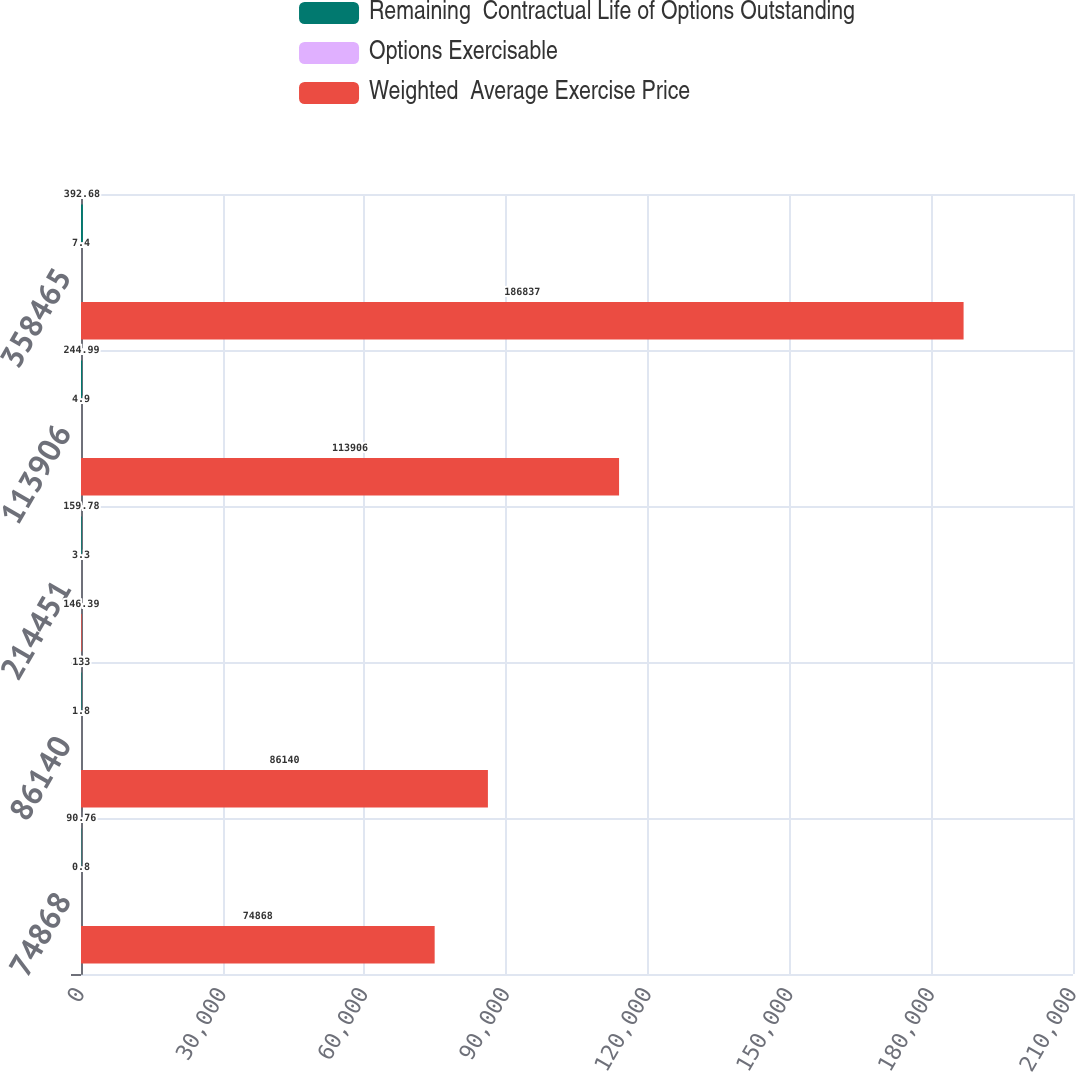Convert chart to OTSL. <chart><loc_0><loc_0><loc_500><loc_500><stacked_bar_chart><ecel><fcel>74868<fcel>86140<fcel>214451<fcel>113906<fcel>358465<nl><fcel>Remaining  Contractual Life of Options Outstanding<fcel>90.76<fcel>133<fcel>159.78<fcel>244.99<fcel>392.68<nl><fcel>Options Exercisable<fcel>0.8<fcel>1.8<fcel>3.3<fcel>4.9<fcel>7.4<nl><fcel>Weighted  Average Exercise Price<fcel>74868<fcel>86140<fcel>146.39<fcel>113906<fcel>186837<nl></chart> 